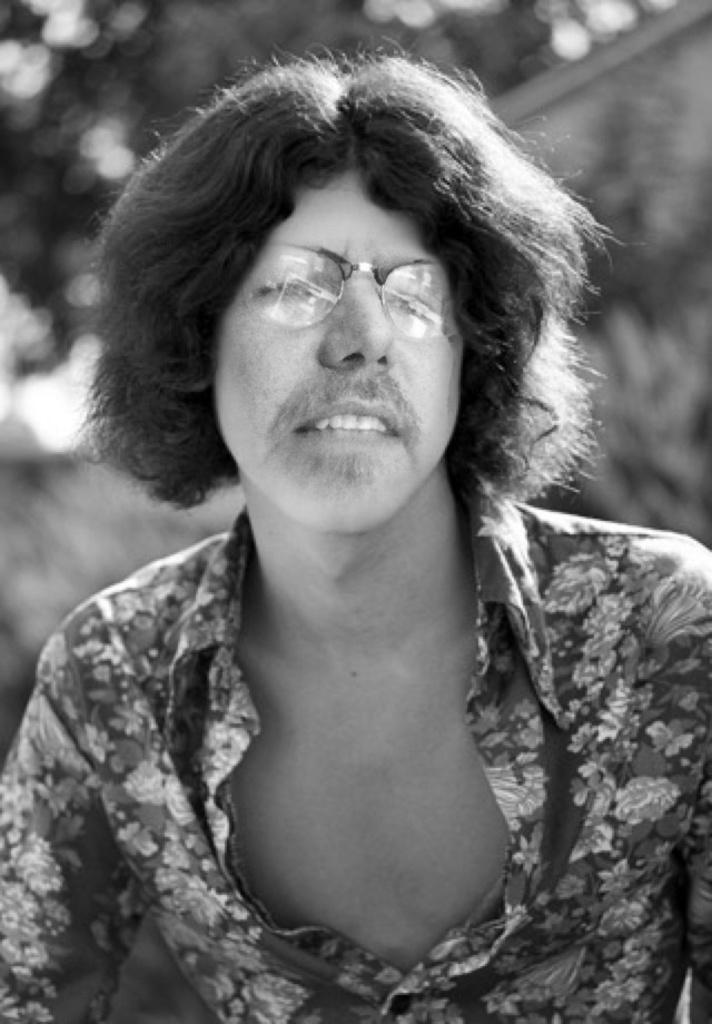What is the color scheme of the image? The image is black and white. Can you describe the person in the image? The person in the image is wearing spectacles. How would you describe the background of the image? The background of the image is blurred. What type of record is the person holding in the image? There is no record present in the image; it is a black and white photograph of a person wearing spectacles with a blurred background. 